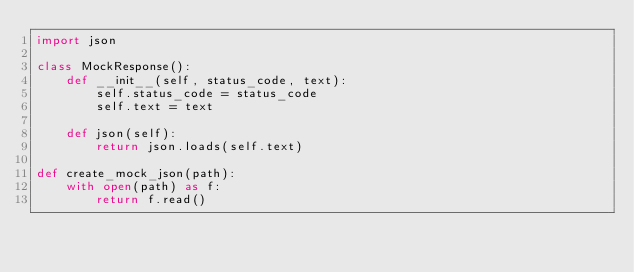Convert code to text. <code><loc_0><loc_0><loc_500><loc_500><_Python_>import json

class MockResponse():
    def __init__(self, status_code, text):
        self.status_code = status_code
        self.text = text

    def json(self):
        return json.loads(self.text)

def create_mock_json(path):
    with open(path) as f:
        return f.read()</code> 